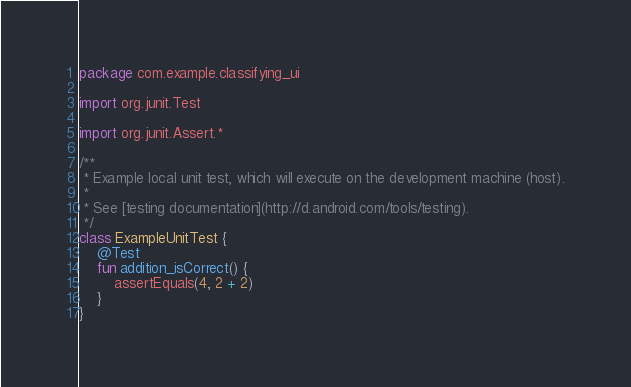<code> <loc_0><loc_0><loc_500><loc_500><_Kotlin_>package com.example.classifying_ui

import org.junit.Test

import org.junit.Assert.*

/**
 * Example local unit test, which will execute on the development machine (host).
 *
 * See [testing documentation](http://d.android.com/tools/testing).
 */
class ExampleUnitTest {
    @Test
    fun addition_isCorrect() {
        assertEquals(4, 2 + 2)
    }
}
</code> 